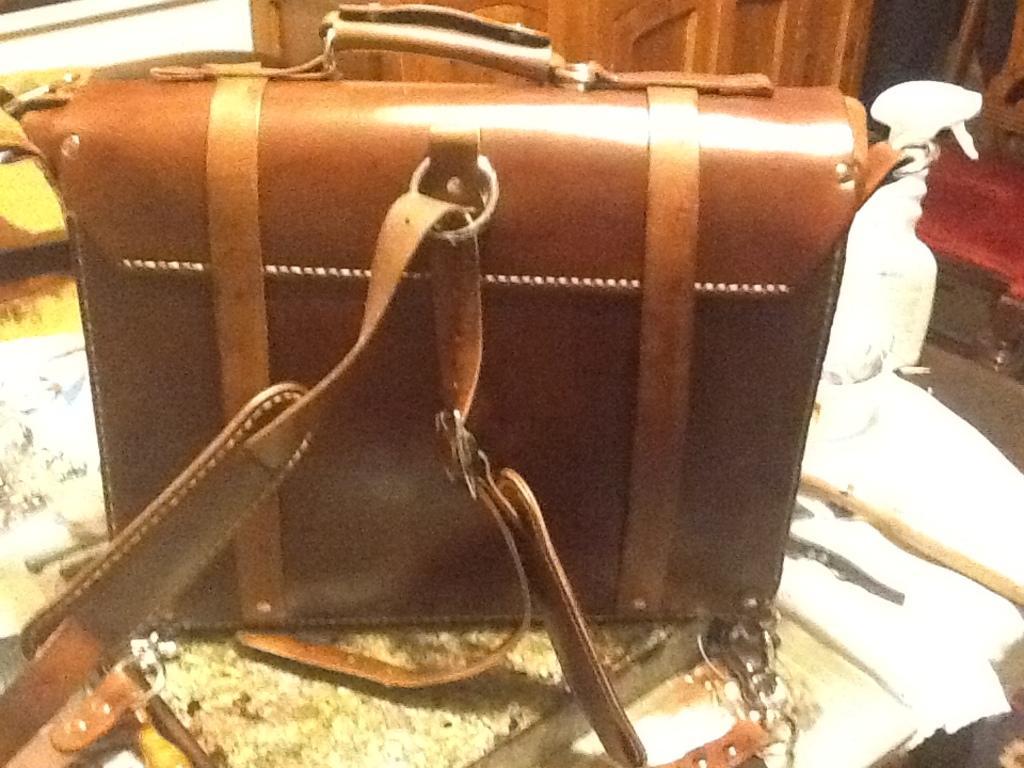Can you describe this image briefly? On the table there is a bag,spray bottle. In the background we can see a door and chair. 